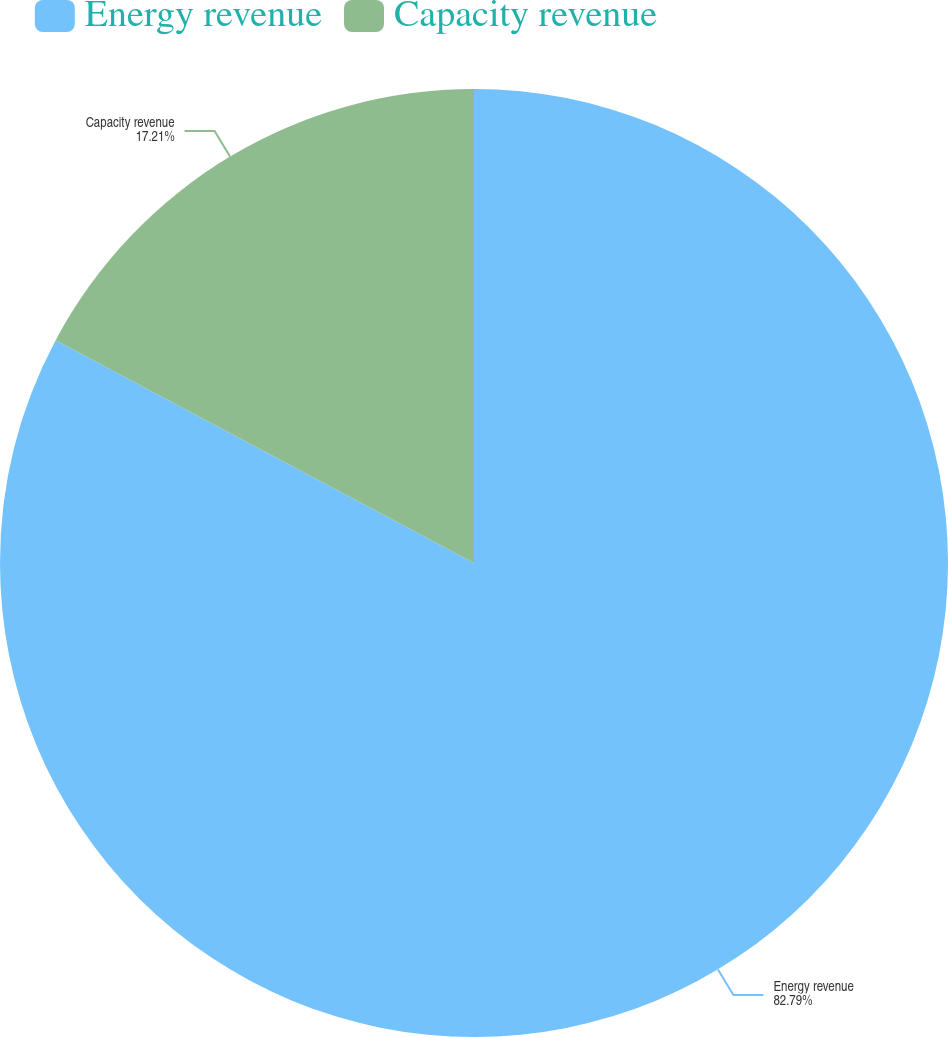Convert chart to OTSL. <chart><loc_0><loc_0><loc_500><loc_500><pie_chart><fcel>Energy revenue<fcel>Capacity revenue<nl><fcel>82.79%<fcel>17.21%<nl></chart> 